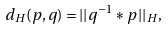<formula> <loc_0><loc_0><loc_500><loc_500>d _ { H } ( p , q ) = | | q ^ { - 1 } \ast p | | _ { H } ,</formula> 